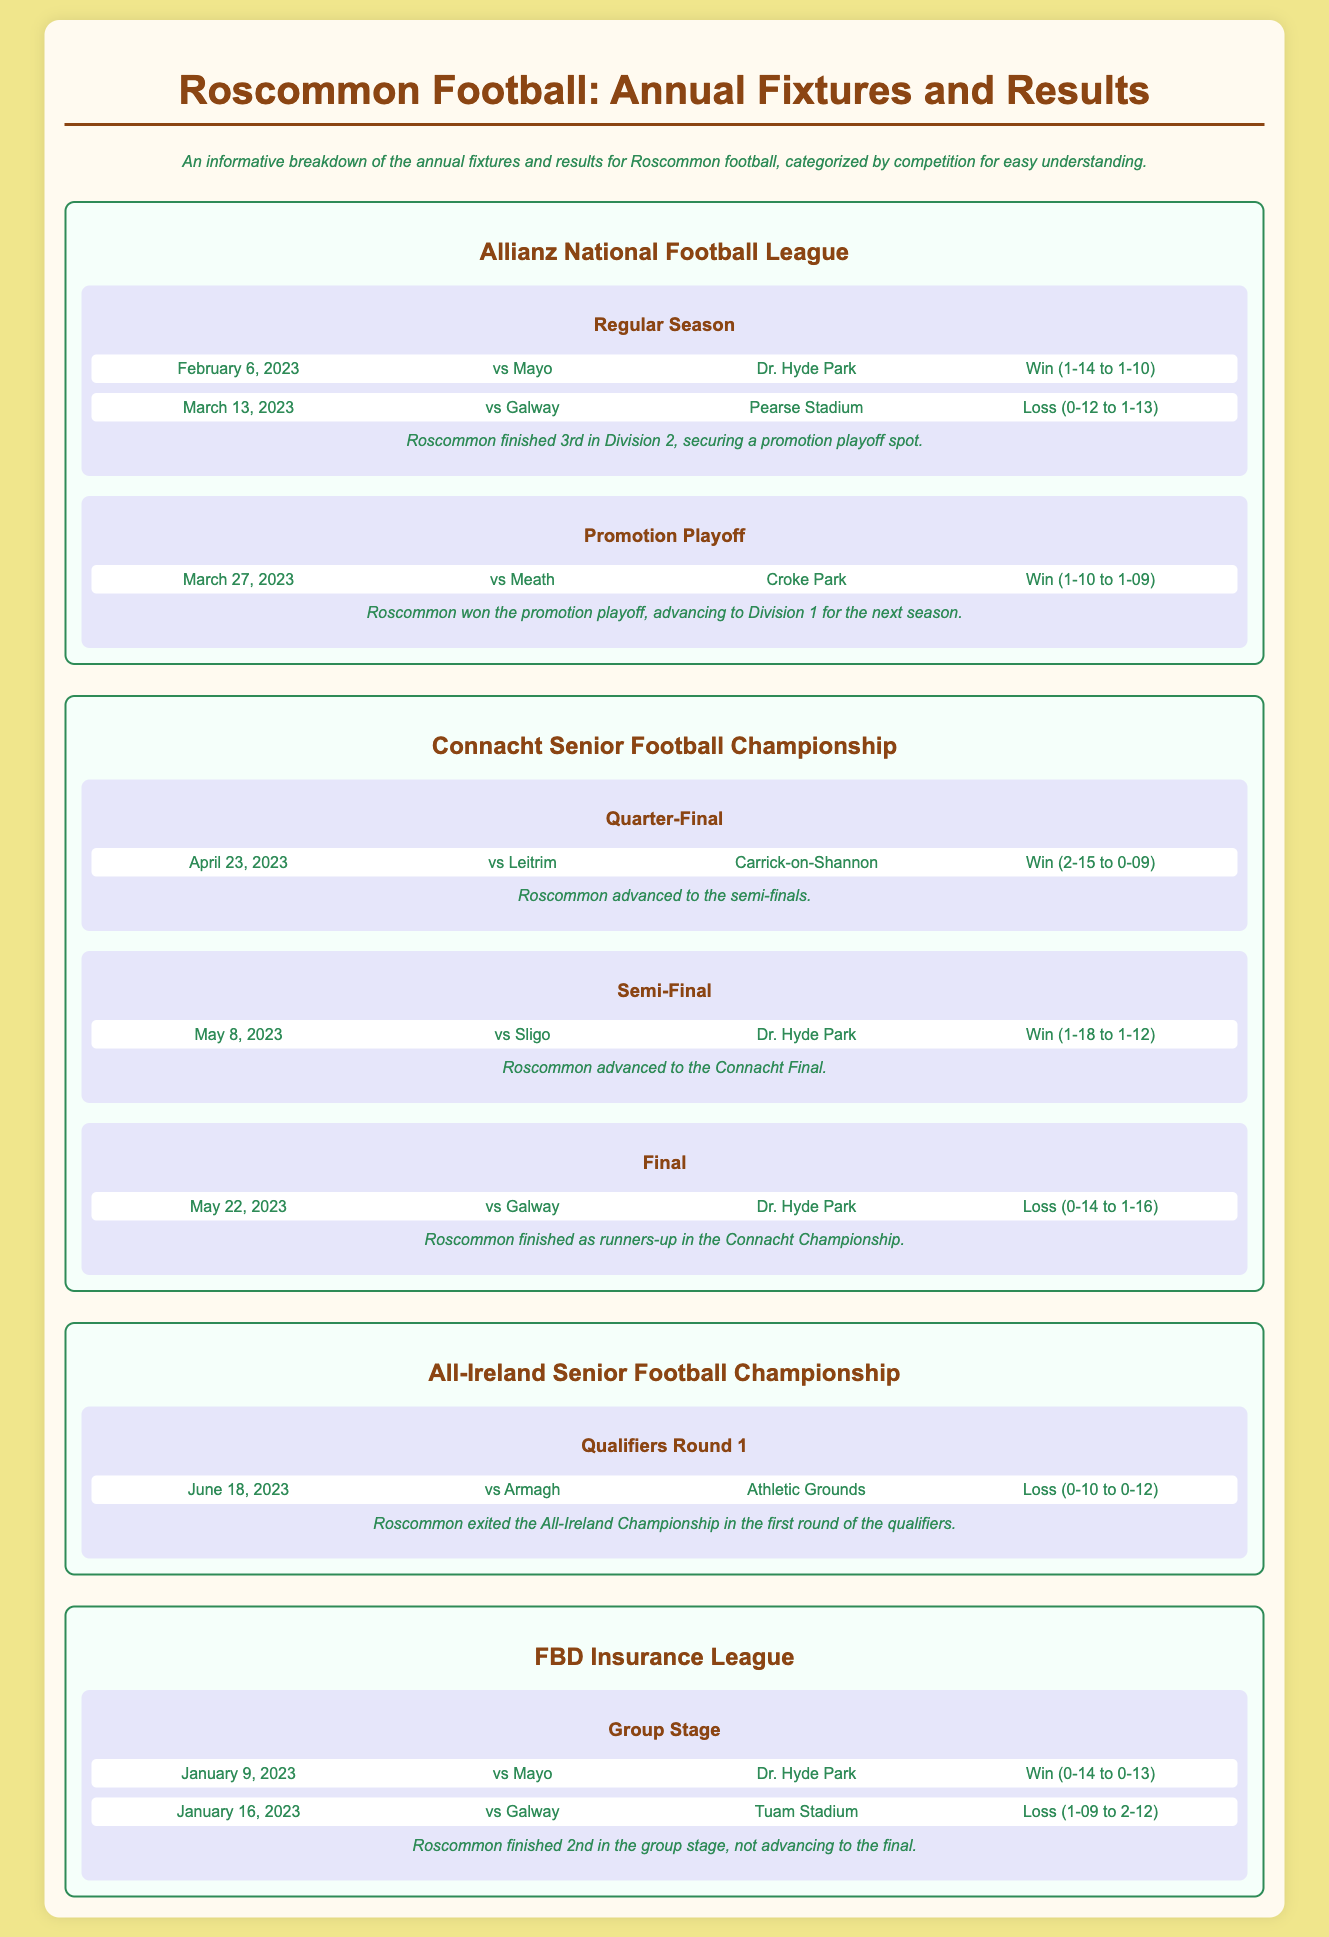What was Roscommon's result against Mayo on February 6, 2023? The result of the match on February 6, 2023, against Mayo was a win with a score of 1-14 to 1-10.
Answer: Win (1-14 to 1-10) What stage did Roscommon reach in the Connacht Senior Football Championship? Roscommon advanced to the final stage of the Connacht Senior Football Championship after winning the quarter-final and semi-final.
Answer: Final How many fixtures were played in the Allianz National Football League? The document lists a total of four fixtures played during the Allianz National Football League.
Answer: 4 What was Roscommon's position in the FBD Insurance League group stage? Roscommon finished in 2nd position in the FBD Insurance League group stage.
Answer: 2nd Which team did Roscommon lose to in the All-Ireland Championship? In the All-Ireland Championship, Roscommon lost to Armagh in the first round of qualifiers.
Answer: Armagh Did Roscommon win or lose their semi-final match in the Connacht Senior Football Championship? The document indicates that Roscommon won their semi-final match against Sligo in the Connacht Senior Football Championship.
Answer: Win How many points did Roscommon score in the Connacht Championship Final? Roscommon scored 14 points during the Connacht Championship Final against Galway.
Answer: 14 What was the date of the Promotion Playoff match? The Promotion Playoff match took place on March 27, 2023.
Answer: March 27, 2023 What was the location of the fixture against Galway on March 13, 2023? The match against Galway on March 13, 2023, was held at Pearse Stadium.
Answer: Pearse Stadium 